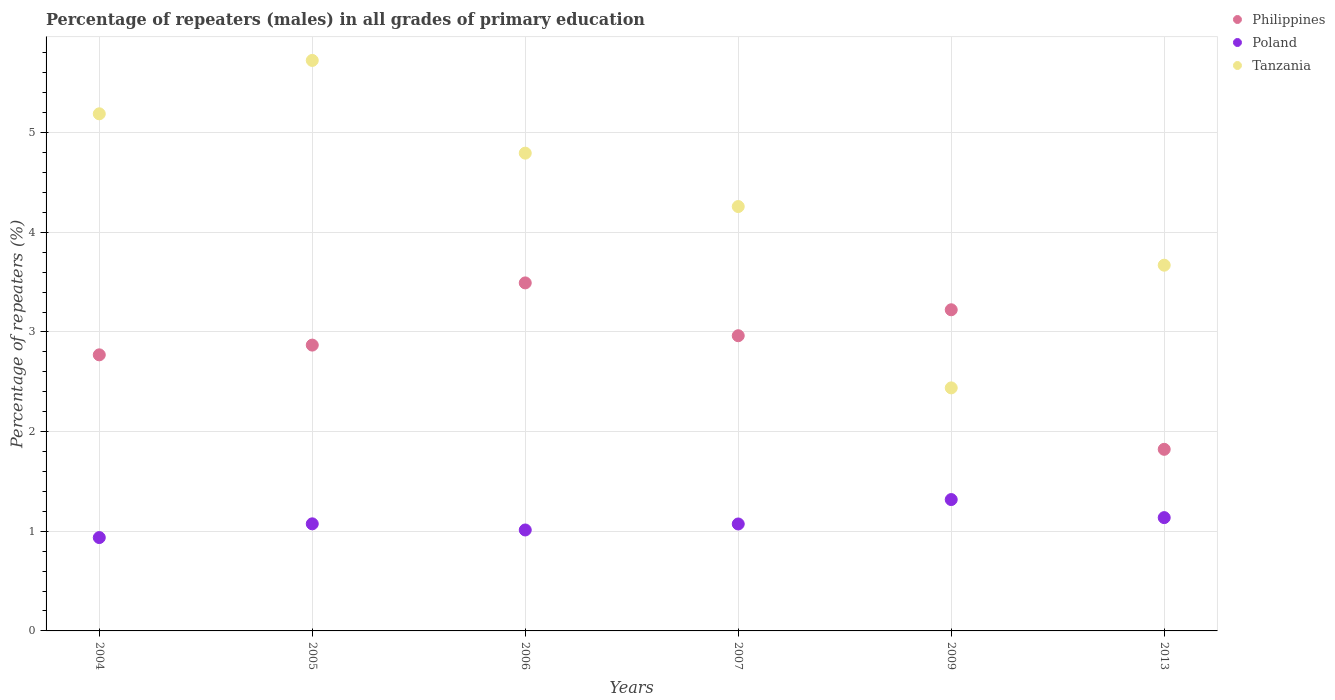Is the number of dotlines equal to the number of legend labels?
Your response must be concise. Yes. What is the percentage of repeaters (males) in Poland in 2007?
Your answer should be very brief. 1.07. Across all years, what is the maximum percentage of repeaters (males) in Philippines?
Provide a succinct answer. 3.49. Across all years, what is the minimum percentage of repeaters (males) in Philippines?
Keep it short and to the point. 1.82. What is the total percentage of repeaters (males) in Philippines in the graph?
Provide a short and direct response. 17.14. What is the difference between the percentage of repeaters (males) in Poland in 2004 and that in 2007?
Offer a terse response. -0.14. What is the difference between the percentage of repeaters (males) in Philippines in 2006 and the percentage of repeaters (males) in Poland in 2007?
Offer a terse response. 2.42. What is the average percentage of repeaters (males) in Poland per year?
Your answer should be compact. 1.09. In the year 2009, what is the difference between the percentage of repeaters (males) in Tanzania and percentage of repeaters (males) in Poland?
Give a very brief answer. 1.12. In how many years, is the percentage of repeaters (males) in Poland greater than 1 %?
Your answer should be very brief. 5. What is the ratio of the percentage of repeaters (males) in Poland in 2006 to that in 2013?
Provide a succinct answer. 0.89. What is the difference between the highest and the second highest percentage of repeaters (males) in Poland?
Make the answer very short. 0.18. What is the difference between the highest and the lowest percentage of repeaters (males) in Philippines?
Your response must be concise. 1.67. Is the sum of the percentage of repeaters (males) in Poland in 2005 and 2006 greater than the maximum percentage of repeaters (males) in Tanzania across all years?
Keep it short and to the point. No. Is it the case that in every year, the sum of the percentage of repeaters (males) in Philippines and percentage of repeaters (males) in Poland  is greater than the percentage of repeaters (males) in Tanzania?
Your response must be concise. No. Does the percentage of repeaters (males) in Philippines monotonically increase over the years?
Give a very brief answer. No. Is the percentage of repeaters (males) in Philippines strictly less than the percentage of repeaters (males) in Poland over the years?
Provide a succinct answer. No. How many dotlines are there?
Offer a very short reply. 3. How many years are there in the graph?
Ensure brevity in your answer.  6. Are the values on the major ticks of Y-axis written in scientific E-notation?
Give a very brief answer. No. Does the graph contain any zero values?
Ensure brevity in your answer.  No. Where does the legend appear in the graph?
Provide a short and direct response. Top right. How many legend labels are there?
Your answer should be compact. 3. What is the title of the graph?
Provide a short and direct response. Percentage of repeaters (males) in all grades of primary education. Does "South Asia" appear as one of the legend labels in the graph?
Your answer should be very brief. No. What is the label or title of the X-axis?
Provide a succinct answer. Years. What is the label or title of the Y-axis?
Give a very brief answer. Percentage of repeaters (%). What is the Percentage of repeaters (%) of Philippines in 2004?
Keep it short and to the point. 2.77. What is the Percentage of repeaters (%) of Poland in 2004?
Make the answer very short. 0.94. What is the Percentage of repeaters (%) of Tanzania in 2004?
Your answer should be very brief. 5.19. What is the Percentage of repeaters (%) in Philippines in 2005?
Make the answer very short. 2.87. What is the Percentage of repeaters (%) of Poland in 2005?
Your answer should be very brief. 1.07. What is the Percentage of repeaters (%) of Tanzania in 2005?
Ensure brevity in your answer.  5.73. What is the Percentage of repeaters (%) in Philippines in 2006?
Your response must be concise. 3.49. What is the Percentage of repeaters (%) of Poland in 2006?
Offer a very short reply. 1.01. What is the Percentage of repeaters (%) in Tanzania in 2006?
Your answer should be very brief. 4.79. What is the Percentage of repeaters (%) of Philippines in 2007?
Give a very brief answer. 2.96. What is the Percentage of repeaters (%) of Poland in 2007?
Provide a short and direct response. 1.07. What is the Percentage of repeaters (%) of Tanzania in 2007?
Provide a succinct answer. 4.26. What is the Percentage of repeaters (%) of Philippines in 2009?
Offer a very short reply. 3.22. What is the Percentage of repeaters (%) of Poland in 2009?
Give a very brief answer. 1.32. What is the Percentage of repeaters (%) of Tanzania in 2009?
Provide a short and direct response. 2.44. What is the Percentage of repeaters (%) in Philippines in 2013?
Keep it short and to the point. 1.82. What is the Percentage of repeaters (%) of Poland in 2013?
Your response must be concise. 1.14. What is the Percentage of repeaters (%) of Tanzania in 2013?
Offer a terse response. 3.67. Across all years, what is the maximum Percentage of repeaters (%) of Philippines?
Offer a very short reply. 3.49. Across all years, what is the maximum Percentage of repeaters (%) of Poland?
Offer a very short reply. 1.32. Across all years, what is the maximum Percentage of repeaters (%) of Tanzania?
Provide a short and direct response. 5.73. Across all years, what is the minimum Percentage of repeaters (%) of Philippines?
Keep it short and to the point. 1.82. Across all years, what is the minimum Percentage of repeaters (%) of Poland?
Make the answer very short. 0.94. Across all years, what is the minimum Percentage of repeaters (%) in Tanzania?
Make the answer very short. 2.44. What is the total Percentage of repeaters (%) in Philippines in the graph?
Provide a succinct answer. 17.14. What is the total Percentage of repeaters (%) of Poland in the graph?
Provide a short and direct response. 6.55. What is the total Percentage of repeaters (%) in Tanzania in the graph?
Offer a terse response. 26.08. What is the difference between the Percentage of repeaters (%) of Philippines in 2004 and that in 2005?
Offer a very short reply. -0.1. What is the difference between the Percentage of repeaters (%) of Poland in 2004 and that in 2005?
Your response must be concise. -0.14. What is the difference between the Percentage of repeaters (%) of Tanzania in 2004 and that in 2005?
Keep it short and to the point. -0.54. What is the difference between the Percentage of repeaters (%) in Philippines in 2004 and that in 2006?
Make the answer very short. -0.72. What is the difference between the Percentage of repeaters (%) of Poland in 2004 and that in 2006?
Keep it short and to the point. -0.08. What is the difference between the Percentage of repeaters (%) of Tanzania in 2004 and that in 2006?
Give a very brief answer. 0.39. What is the difference between the Percentage of repeaters (%) in Philippines in 2004 and that in 2007?
Make the answer very short. -0.19. What is the difference between the Percentage of repeaters (%) in Poland in 2004 and that in 2007?
Offer a very short reply. -0.14. What is the difference between the Percentage of repeaters (%) of Tanzania in 2004 and that in 2007?
Provide a short and direct response. 0.93. What is the difference between the Percentage of repeaters (%) of Philippines in 2004 and that in 2009?
Keep it short and to the point. -0.45. What is the difference between the Percentage of repeaters (%) in Poland in 2004 and that in 2009?
Offer a very short reply. -0.38. What is the difference between the Percentage of repeaters (%) in Tanzania in 2004 and that in 2009?
Make the answer very short. 2.75. What is the difference between the Percentage of repeaters (%) in Philippines in 2004 and that in 2013?
Offer a very short reply. 0.95. What is the difference between the Percentage of repeaters (%) in Poland in 2004 and that in 2013?
Offer a very short reply. -0.2. What is the difference between the Percentage of repeaters (%) of Tanzania in 2004 and that in 2013?
Offer a very short reply. 1.52. What is the difference between the Percentage of repeaters (%) of Philippines in 2005 and that in 2006?
Offer a terse response. -0.62. What is the difference between the Percentage of repeaters (%) in Poland in 2005 and that in 2006?
Your response must be concise. 0.06. What is the difference between the Percentage of repeaters (%) of Tanzania in 2005 and that in 2006?
Make the answer very short. 0.93. What is the difference between the Percentage of repeaters (%) in Philippines in 2005 and that in 2007?
Ensure brevity in your answer.  -0.09. What is the difference between the Percentage of repeaters (%) in Poland in 2005 and that in 2007?
Your response must be concise. 0. What is the difference between the Percentage of repeaters (%) of Tanzania in 2005 and that in 2007?
Provide a short and direct response. 1.47. What is the difference between the Percentage of repeaters (%) in Philippines in 2005 and that in 2009?
Keep it short and to the point. -0.35. What is the difference between the Percentage of repeaters (%) in Poland in 2005 and that in 2009?
Provide a short and direct response. -0.24. What is the difference between the Percentage of repeaters (%) in Tanzania in 2005 and that in 2009?
Your response must be concise. 3.29. What is the difference between the Percentage of repeaters (%) in Philippines in 2005 and that in 2013?
Ensure brevity in your answer.  1.05. What is the difference between the Percentage of repeaters (%) of Poland in 2005 and that in 2013?
Ensure brevity in your answer.  -0.06. What is the difference between the Percentage of repeaters (%) in Tanzania in 2005 and that in 2013?
Offer a very short reply. 2.05. What is the difference between the Percentage of repeaters (%) in Philippines in 2006 and that in 2007?
Provide a short and direct response. 0.53. What is the difference between the Percentage of repeaters (%) in Poland in 2006 and that in 2007?
Your answer should be very brief. -0.06. What is the difference between the Percentage of repeaters (%) of Tanzania in 2006 and that in 2007?
Make the answer very short. 0.54. What is the difference between the Percentage of repeaters (%) of Philippines in 2006 and that in 2009?
Keep it short and to the point. 0.27. What is the difference between the Percentage of repeaters (%) in Poland in 2006 and that in 2009?
Offer a very short reply. -0.31. What is the difference between the Percentage of repeaters (%) in Tanzania in 2006 and that in 2009?
Ensure brevity in your answer.  2.36. What is the difference between the Percentage of repeaters (%) of Philippines in 2006 and that in 2013?
Keep it short and to the point. 1.67. What is the difference between the Percentage of repeaters (%) of Poland in 2006 and that in 2013?
Your answer should be compact. -0.12. What is the difference between the Percentage of repeaters (%) of Tanzania in 2006 and that in 2013?
Give a very brief answer. 1.12. What is the difference between the Percentage of repeaters (%) of Philippines in 2007 and that in 2009?
Your answer should be compact. -0.26. What is the difference between the Percentage of repeaters (%) in Poland in 2007 and that in 2009?
Offer a very short reply. -0.24. What is the difference between the Percentage of repeaters (%) in Tanzania in 2007 and that in 2009?
Offer a terse response. 1.82. What is the difference between the Percentage of repeaters (%) in Philippines in 2007 and that in 2013?
Ensure brevity in your answer.  1.14. What is the difference between the Percentage of repeaters (%) in Poland in 2007 and that in 2013?
Ensure brevity in your answer.  -0.06. What is the difference between the Percentage of repeaters (%) of Tanzania in 2007 and that in 2013?
Provide a succinct answer. 0.59. What is the difference between the Percentage of repeaters (%) in Philippines in 2009 and that in 2013?
Your response must be concise. 1.4. What is the difference between the Percentage of repeaters (%) in Poland in 2009 and that in 2013?
Your response must be concise. 0.18. What is the difference between the Percentage of repeaters (%) of Tanzania in 2009 and that in 2013?
Your response must be concise. -1.23. What is the difference between the Percentage of repeaters (%) of Philippines in 2004 and the Percentage of repeaters (%) of Poland in 2005?
Offer a very short reply. 1.7. What is the difference between the Percentage of repeaters (%) of Philippines in 2004 and the Percentage of repeaters (%) of Tanzania in 2005?
Your response must be concise. -2.95. What is the difference between the Percentage of repeaters (%) in Poland in 2004 and the Percentage of repeaters (%) in Tanzania in 2005?
Offer a very short reply. -4.79. What is the difference between the Percentage of repeaters (%) in Philippines in 2004 and the Percentage of repeaters (%) in Poland in 2006?
Give a very brief answer. 1.76. What is the difference between the Percentage of repeaters (%) in Philippines in 2004 and the Percentage of repeaters (%) in Tanzania in 2006?
Keep it short and to the point. -2.02. What is the difference between the Percentage of repeaters (%) of Poland in 2004 and the Percentage of repeaters (%) of Tanzania in 2006?
Your response must be concise. -3.86. What is the difference between the Percentage of repeaters (%) of Philippines in 2004 and the Percentage of repeaters (%) of Poland in 2007?
Your answer should be compact. 1.7. What is the difference between the Percentage of repeaters (%) in Philippines in 2004 and the Percentage of repeaters (%) in Tanzania in 2007?
Provide a succinct answer. -1.49. What is the difference between the Percentage of repeaters (%) of Poland in 2004 and the Percentage of repeaters (%) of Tanzania in 2007?
Your answer should be compact. -3.32. What is the difference between the Percentage of repeaters (%) in Philippines in 2004 and the Percentage of repeaters (%) in Poland in 2009?
Offer a very short reply. 1.45. What is the difference between the Percentage of repeaters (%) of Philippines in 2004 and the Percentage of repeaters (%) of Tanzania in 2009?
Keep it short and to the point. 0.33. What is the difference between the Percentage of repeaters (%) in Poland in 2004 and the Percentage of repeaters (%) in Tanzania in 2009?
Your answer should be very brief. -1.5. What is the difference between the Percentage of repeaters (%) of Philippines in 2004 and the Percentage of repeaters (%) of Poland in 2013?
Offer a terse response. 1.63. What is the difference between the Percentage of repeaters (%) in Philippines in 2004 and the Percentage of repeaters (%) in Tanzania in 2013?
Keep it short and to the point. -0.9. What is the difference between the Percentage of repeaters (%) in Poland in 2004 and the Percentage of repeaters (%) in Tanzania in 2013?
Your response must be concise. -2.73. What is the difference between the Percentage of repeaters (%) in Philippines in 2005 and the Percentage of repeaters (%) in Poland in 2006?
Keep it short and to the point. 1.86. What is the difference between the Percentage of repeaters (%) in Philippines in 2005 and the Percentage of repeaters (%) in Tanzania in 2006?
Offer a very short reply. -1.93. What is the difference between the Percentage of repeaters (%) of Poland in 2005 and the Percentage of repeaters (%) of Tanzania in 2006?
Your answer should be very brief. -3.72. What is the difference between the Percentage of repeaters (%) of Philippines in 2005 and the Percentage of repeaters (%) of Poland in 2007?
Make the answer very short. 1.8. What is the difference between the Percentage of repeaters (%) in Philippines in 2005 and the Percentage of repeaters (%) in Tanzania in 2007?
Offer a very short reply. -1.39. What is the difference between the Percentage of repeaters (%) of Poland in 2005 and the Percentage of repeaters (%) of Tanzania in 2007?
Provide a short and direct response. -3.18. What is the difference between the Percentage of repeaters (%) in Philippines in 2005 and the Percentage of repeaters (%) in Poland in 2009?
Provide a succinct answer. 1.55. What is the difference between the Percentage of repeaters (%) of Philippines in 2005 and the Percentage of repeaters (%) of Tanzania in 2009?
Your response must be concise. 0.43. What is the difference between the Percentage of repeaters (%) of Poland in 2005 and the Percentage of repeaters (%) of Tanzania in 2009?
Make the answer very short. -1.36. What is the difference between the Percentage of repeaters (%) of Philippines in 2005 and the Percentage of repeaters (%) of Poland in 2013?
Your response must be concise. 1.73. What is the difference between the Percentage of repeaters (%) in Philippines in 2005 and the Percentage of repeaters (%) in Tanzania in 2013?
Provide a short and direct response. -0.8. What is the difference between the Percentage of repeaters (%) of Poland in 2005 and the Percentage of repeaters (%) of Tanzania in 2013?
Offer a very short reply. -2.6. What is the difference between the Percentage of repeaters (%) of Philippines in 2006 and the Percentage of repeaters (%) of Poland in 2007?
Ensure brevity in your answer.  2.42. What is the difference between the Percentage of repeaters (%) of Philippines in 2006 and the Percentage of repeaters (%) of Tanzania in 2007?
Your answer should be very brief. -0.77. What is the difference between the Percentage of repeaters (%) of Poland in 2006 and the Percentage of repeaters (%) of Tanzania in 2007?
Make the answer very short. -3.25. What is the difference between the Percentage of repeaters (%) of Philippines in 2006 and the Percentage of repeaters (%) of Poland in 2009?
Offer a very short reply. 2.17. What is the difference between the Percentage of repeaters (%) of Philippines in 2006 and the Percentage of repeaters (%) of Tanzania in 2009?
Your response must be concise. 1.05. What is the difference between the Percentage of repeaters (%) in Poland in 2006 and the Percentage of repeaters (%) in Tanzania in 2009?
Provide a succinct answer. -1.43. What is the difference between the Percentage of repeaters (%) in Philippines in 2006 and the Percentage of repeaters (%) in Poland in 2013?
Offer a terse response. 2.36. What is the difference between the Percentage of repeaters (%) in Philippines in 2006 and the Percentage of repeaters (%) in Tanzania in 2013?
Provide a succinct answer. -0.18. What is the difference between the Percentage of repeaters (%) in Poland in 2006 and the Percentage of repeaters (%) in Tanzania in 2013?
Offer a terse response. -2.66. What is the difference between the Percentage of repeaters (%) in Philippines in 2007 and the Percentage of repeaters (%) in Poland in 2009?
Provide a short and direct response. 1.64. What is the difference between the Percentage of repeaters (%) of Philippines in 2007 and the Percentage of repeaters (%) of Tanzania in 2009?
Provide a succinct answer. 0.52. What is the difference between the Percentage of repeaters (%) of Poland in 2007 and the Percentage of repeaters (%) of Tanzania in 2009?
Offer a very short reply. -1.37. What is the difference between the Percentage of repeaters (%) of Philippines in 2007 and the Percentage of repeaters (%) of Poland in 2013?
Provide a succinct answer. 1.83. What is the difference between the Percentage of repeaters (%) of Philippines in 2007 and the Percentage of repeaters (%) of Tanzania in 2013?
Keep it short and to the point. -0.71. What is the difference between the Percentage of repeaters (%) of Poland in 2007 and the Percentage of repeaters (%) of Tanzania in 2013?
Offer a very short reply. -2.6. What is the difference between the Percentage of repeaters (%) of Philippines in 2009 and the Percentage of repeaters (%) of Poland in 2013?
Provide a succinct answer. 2.09. What is the difference between the Percentage of repeaters (%) of Philippines in 2009 and the Percentage of repeaters (%) of Tanzania in 2013?
Provide a succinct answer. -0.45. What is the difference between the Percentage of repeaters (%) in Poland in 2009 and the Percentage of repeaters (%) in Tanzania in 2013?
Make the answer very short. -2.35. What is the average Percentage of repeaters (%) of Philippines per year?
Keep it short and to the point. 2.86. What is the average Percentage of repeaters (%) in Poland per year?
Provide a succinct answer. 1.09. What is the average Percentage of repeaters (%) in Tanzania per year?
Keep it short and to the point. 4.35. In the year 2004, what is the difference between the Percentage of repeaters (%) in Philippines and Percentage of repeaters (%) in Poland?
Your answer should be very brief. 1.83. In the year 2004, what is the difference between the Percentage of repeaters (%) of Philippines and Percentage of repeaters (%) of Tanzania?
Make the answer very short. -2.42. In the year 2004, what is the difference between the Percentage of repeaters (%) of Poland and Percentage of repeaters (%) of Tanzania?
Ensure brevity in your answer.  -4.25. In the year 2005, what is the difference between the Percentage of repeaters (%) in Philippines and Percentage of repeaters (%) in Poland?
Keep it short and to the point. 1.79. In the year 2005, what is the difference between the Percentage of repeaters (%) of Philippines and Percentage of repeaters (%) of Tanzania?
Offer a terse response. -2.86. In the year 2005, what is the difference between the Percentage of repeaters (%) in Poland and Percentage of repeaters (%) in Tanzania?
Give a very brief answer. -4.65. In the year 2006, what is the difference between the Percentage of repeaters (%) in Philippines and Percentage of repeaters (%) in Poland?
Provide a succinct answer. 2.48. In the year 2006, what is the difference between the Percentage of repeaters (%) in Philippines and Percentage of repeaters (%) in Tanzania?
Give a very brief answer. -1.3. In the year 2006, what is the difference between the Percentage of repeaters (%) of Poland and Percentage of repeaters (%) of Tanzania?
Ensure brevity in your answer.  -3.78. In the year 2007, what is the difference between the Percentage of repeaters (%) in Philippines and Percentage of repeaters (%) in Poland?
Your answer should be very brief. 1.89. In the year 2007, what is the difference between the Percentage of repeaters (%) of Philippines and Percentage of repeaters (%) of Tanzania?
Provide a succinct answer. -1.3. In the year 2007, what is the difference between the Percentage of repeaters (%) in Poland and Percentage of repeaters (%) in Tanzania?
Offer a very short reply. -3.19. In the year 2009, what is the difference between the Percentage of repeaters (%) in Philippines and Percentage of repeaters (%) in Poland?
Provide a short and direct response. 1.9. In the year 2009, what is the difference between the Percentage of repeaters (%) in Philippines and Percentage of repeaters (%) in Tanzania?
Ensure brevity in your answer.  0.78. In the year 2009, what is the difference between the Percentage of repeaters (%) of Poland and Percentage of repeaters (%) of Tanzania?
Provide a short and direct response. -1.12. In the year 2013, what is the difference between the Percentage of repeaters (%) of Philippines and Percentage of repeaters (%) of Poland?
Offer a terse response. 0.69. In the year 2013, what is the difference between the Percentage of repeaters (%) in Philippines and Percentage of repeaters (%) in Tanzania?
Your answer should be very brief. -1.85. In the year 2013, what is the difference between the Percentage of repeaters (%) of Poland and Percentage of repeaters (%) of Tanzania?
Provide a short and direct response. -2.53. What is the ratio of the Percentage of repeaters (%) of Philippines in 2004 to that in 2005?
Offer a terse response. 0.97. What is the ratio of the Percentage of repeaters (%) in Poland in 2004 to that in 2005?
Your response must be concise. 0.87. What is the ratio of the Percentage of repeaters (%) of Tanzania in 2004 to that in 2005?
Offer a very short reply. 0.91. What is the ratio of the Percentage of repeaters (%) in Philippines in 2004 to that in 2006?
Your answer should be very brief. 0.79. What is the ratio of the Percentage of repeaters (%) in Poland in 2004 to that in 2006?
Give a very brief answer. 0.92. What is the ratio of the Percentage of repeaters (%) in Tanzania in 2004 to that in 2006?
Offer a very short reply. 1.08. What is the ratio of the Percentage of repeaters (%) in Philippines in 2004 to that in 2007?
Offer a very short reply. 0.94. What is the ratio of the Percentage of repeaters (%) in Poland in 2004 to that in 2007?
Your response must be concise. 0.87. What is the ratio of the Percentage of repeaters (%) of Tanzania in 2004 to that in 2007?
Your response must be concise. 1.22. What is the ratio of the Percentage of repeaters (%) in Philippines in 2004 to that in 2009?
Make the answer very short. 0.86. What is the ratio of the Percentage of repeaters (%) in Poland in 2004 to that in 2009?
Your response must be concise. 0.71. What is the ratio of the Percentage of repeaters (%) of Tanzania in 2004 to that in 2009?
Offer a terse response. 2.13. What is the ratio of the Percentage of repeaters (%) of Philippines in 2004 to that in 2013?
Your answer should be compact. 1.52. What is the ratio of the Percentage of repeaters (%) in Poland in 2004 to that in 2013?
Your answer should be very brief. 0.82. What is the ratio of the Percentage of repeaters (%) of Tanzania in 2004 to that in 2013?
Keep it short and to the point. 1.41. What is the ratio of the Percentage of repeaters (%) in Philippines in 2005 to that in 2006?
Offer a terse response. 0.82. What is the ratio of the Percentage of repeaters (%) of Poland in 2005 to that in 2006?
Provide a short and direct response. 1.06. What is the ratio of the Percentage of repeaters (%) of Tanzania in 2005 to that in 2006?
Your response must be concise. 1.19. What is the ratio of the Percentage of repeaters (%) of Philippines in 2005 to that in 2007?
Make the answer very short. 0.97. What is the ratio of the Percentage of repeaters (%) of Tanzania in 2005 to that in 2007?
Your answer should be compact. 1.34. What is the ratio of the Percentage of repeaters (%) of Philippines in 2005 to that in 2009?
Your answer should be compact. 0.89. What is the ratio of the Percentage of repeaters (%) in Poland in 2005 to that in 2009?
Provide a succinct answer. 0.82. What is the ratio of the Percentage of repeaters (%) in Tanzania in 2005 to that in 2009?
Offer a very short reply. 2.35. What is the ratio of the Percentage of repeaters (%) in Philippines in 2005 to that in 2013?
Provide a succinct answer. 1.57. What is the ratio of the Percentage of repeaters (%) in Poland in 2005 to that in 2013?
Provide a short and direct response. 0.95. What is the ratio of the Percentage of repeaters (%) of Tanzania in 2005 to that in 2013?
Your response must be concise. 1.56. What is the ratio of the Percentage of repeaters (%) of Philippines in 2006 to that in 2007?
Your response must be concise. 1.18. What is the ratio of the Percentage of repeaters (%) of Poland in 2006 to that in 2007?
Your answer should be very brief. 0.94. What is the ratio of the Percentage of repeaters (%) in Tanzania in 2006 to that in 2007?
Ensure brevity in your answer.  1.13. What is the ratio of the Percentage of repeaters (%) of Philippines in 2006 to that in 2009?
Give a very brief answer. 1.08. What is the ratio of the Percentage of repeaters (%) in Poland in 2006 to that in 2009?
Give a very brief answer. 0.77. What is the ratio of the Percentage of repeaters (%) of Tanzania in 2006 to that in 2009?
Provide a succinct answer. 1.97. What is the ratio of the Percentage of repeaters (%) of Philippines in 2006 to that in 2013?
Your answer should be very brief. 1.92. What is the ratio of the Percentage of repeaters (%) in Poland in 2006 to that in 2013?
Make the answer very short. 0.89. What is the ratio of the Percentage of repeaters (%) of Tanzania in 2006 to that in 2013?
Your response must be concise. 1.31. What is the ratio of the Percentage of repeaters (%) of Philippines in 2007 to that in 2009?
Provide a succinct answer. 0.92. What is the ratio of the Percentage of repeaters (%) of Poland in 2007 to that in 2009?
Provide a short and direct response. 0.81. What is the ratio of the Percentage of repeaters (%) in Tanzania in 2007 to that in 2009?
Ensure brevity in your answer.  1.75. What is the ratio of the Percentage of repeaters (%) in Philippines in 2007 to that in 2013?
Provide a succinct answer. 1.63. What is the ratio of the Percentage of repeaters (%) in Poland in 2007 to that in 2013?
Your response must be concise. 0.94. What is the ratio of the Percentage of repeaters (%) in Tanzania in 2007 to that in 2013?
Your response must be concise. 1.16. What is the ratio of the Percentage of repeaters (%) in Philippines in 2009 to that in 2013?
Offer a terse response. 1.77. What is the ratio of the Percentage of repeaters (%) of Poland in 2009 to that in 2013?
Give a very brief answer. 1.16. What is the ratio of the Percentage of repeaters (%) of Tanzania in 2009 to that in 2013?
Provide a succinct answer. 0.66. What is the difference between the highest and the second highest Percentage of repeaters (%) in Philippines?
Your response must be concise. 0.27. What is the difference between the highest and the second highest Percentage of repeaters (%) of Poland?
Make the answer very short. 0.18. What is the difference between the highest and the second highest Percentage of repeaters (%) of Tanzania?
Make the answer very short. 0.54. What is the difference between the highest and the lowest Percentage of repeaters (%) in Philippines?
Your response must be concise. 1.67. What is the difference between the highest and the lowest Percentage of repeaters (%) in Poland?
Offer a very short reply. 0.38. What is the difference between the highest and the lowest Percentage of repeaters (%) of Tanzania?
Give a very brief answer. 3.29. 